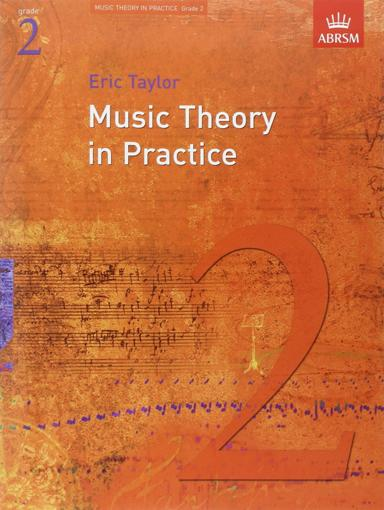What is the title of the book in the image? The title of the book is "Music Theory in Practice." Who is the author of the book in the image? The author of the book is Eric Taylor. What organization is associated with the book? ABRSM (Associated Board of the Royal Schools of Music) is associated with the book. 